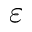<formula> <loc_0><loc_0><loc_500><loc_500>\varepsilon</formula> 